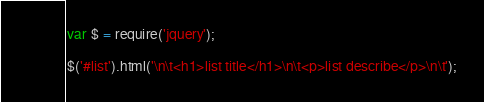Convert code to text. <code><loc_0><loc_0><loc_500><loc_500><_JavaScript_>var $ = require('jquery');

$('#list').html('\n\t<h1>list title</h1>\n\t<p>list describe</p>\n\t');</code> 